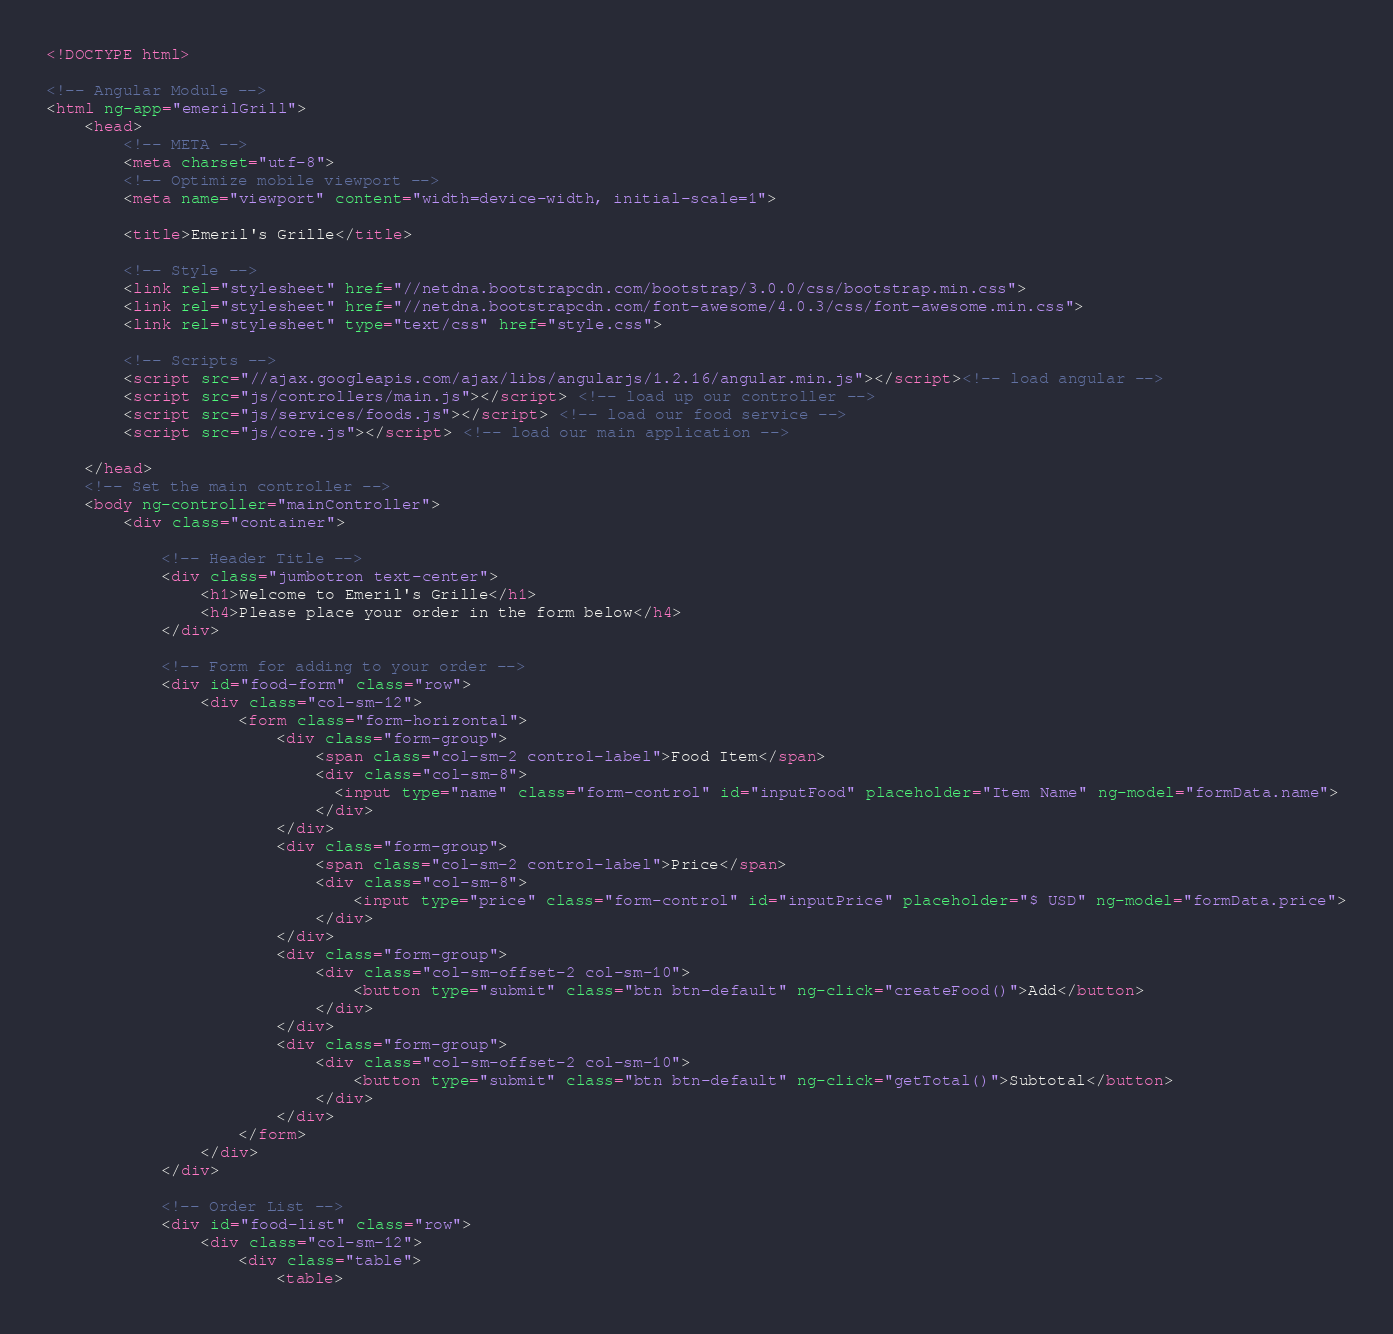<code> <loc_0><loc_0><loc_500><loc_500><_HTML_><!DOCTYPE html>

<!-- Angular Module -->
<html ng-app="emerilGrill">
  	<head>
	    <!-- META -->
	    <meta charset="utf-8">
	    <!-- Optimize mobile viewport -->
	    <meta name="viewport" content="width=device-width, initial-scale=1">

	    <title>Emeril's Grille</title>

	    <!-- Style -->
	    <link rel="stylesheet" href="//netdna.bootstrapcdn.com/bootstrap/3.0.0/css/bootstrap.min.css">
	    <link rel="stylesheet" href="//netdna.bootstrapcdn.com/font-awesome/4.0.3/css/font-awesome.min.css">
	    <link rel="stylesheet" type="text/css" href="style.css">

	    <!-- Scripts -->
	    <script src="//ajax.googleapis.com/ajax/libs/angularjs/1.2.16/angular.min.js"></script><!-- load angular -->
	    <script src="js/controllers/main.js"></script> <!-- load up our controller -->
	    <script src="js/services/foods.js"></script> <!-- load our food service -->
	    <script src="js/core.js"></script> <!-- load our main application -->

	</head>
  	<!-- Set the main controller -->
	<body ng-controller="mainController">
		<div class="container">

			<!-- Header Title -->
			<div class="jumbotron text-center">
				<h1>Welcome to Emeril's Grille</h1>
				<h4>Please place your order in the form below</h4>
			</div>

			<!-- Form for adding to your order -->
			<div id="food-form" class="row">
				<div class="col-sm-12">
					<form class="form-horizontal">
						<div class="form-group">
						    <span class="col-sm-2 control-label">Food Item</span>
						    <div class="col-sm-8">
						      <input type="name" class="form-control" id="inputFood" placeholder="Item Name" ng-model="formData.name">
						    </div>
						</div>
					    <div class="form-group">
					    	<span class="col-sm-2 control-label">Price</span>
					    	<div class="col-sm-8">
					      		<input type="price" class="form-control" id="inputPrice" placeholder="$ USD" ng-model="formData.price">
					    	</div>
					  	</div>
					  	<div class="form-group">
					    	<div class="col-sm-offset-2 col-sm-10">
					      		<button type="submit" class="btn btn-default" ng-click="createFood()">Add</button>
					    	</div>
					  	</div>  
					  	<div class="form-group">  
					    	<div class="col-sm-offset-2 col-sm-10">
					      		<button type="submit" class="btn btn-default" ng-click="getTotal()">Subtotal</button>
					    	</div>
					  	</div>
					</form>
				</div>
			</div>

			<!-- Order List -->
			<div id="food-list" class="row">
				<div class="col-sm-12">
					<div class="table">
						<table></code> 